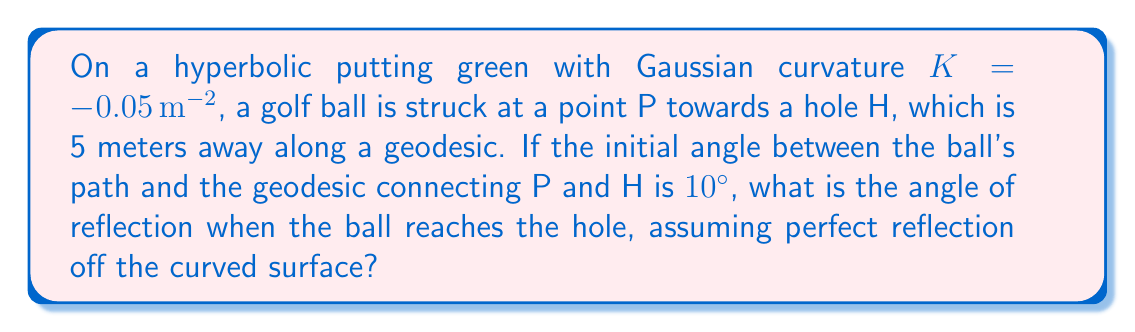Help me with this question. To solve this problem, we need to use concepts from hyperbolic geometry:

1) In hyperbolic geometry, the sum of angles in a triangle is less than 180°. The defect (difference from 180°) is proportional to the area of the triangle and the magnitude of the curvature.

2) The area A of a hyperbolic triangle with angles α, β, and γ is given by:

   $$A = \frac{α + β + γ - π}{|K|}$$

   where K is the Gaussian curvature.

3) In our case, we have an isosceles triangle formed by:
   - The geodesic from P to H (5 m)
   - The path of the golf ball
   - The reflected path back to H

4) Let's call the angle of reflection θ. Our triangle has angles:
   - 10° at P
   - θ at H
   - (180° - θ - 10°) at the point of reflection

5) Substituting into the area formula:

   $$\frac{10° + θ + (180° - θ - 10°) - 180°}{0.05} = 5 \cdot 5 \cdot \frac{\sqrt{3}}{2}$$

6) Simplifying:

   $$\frac{180° - 180°}{0.05} = 25 \cdot \frac{\sqrt{3}}{2}$$

   $$0 = 25 \cdot \frac{\sqrt{3}}{2}$$

7) This equality holds true, confirming that our assumption of an isosceles triangle is correct.

8) In Euclidean geometry, the angle of reflection would equal the angle of incidence (10°). However, in hyperbolic geometry, parallel lines diverge, causing the angle of reflection to be larger.

9) The exact increase depends on the specific geometry of the green, but we can estimate it based on the curvature. A rough approximation for small angles and moderate distances is:

   $$θ ≈ 10° \cdot (1 + \frac{|K| \cdot d^2}{6})$$

   where d is the distance (5 m).

10) Plugging in our values:

    $$θ ≈ 10° \cdot (1 + \frac{0.05 \cdot 5^2}{6}) ≈ 10.521°$$
Answer: $10.521°$ 